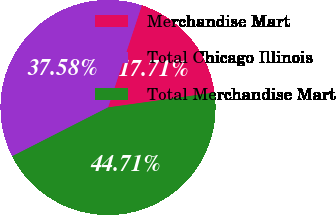Convert chart. <chart><loc_0><loc_0><loc_500><loc_500><pie_chart><fcel>Merchandise Mart<fcel>Total Chicago Illinois<fcel>Total Merchandise Mart<nl><fcel>17.71%<fcel>37.58%<fcel>44.71%<nl></chart> 